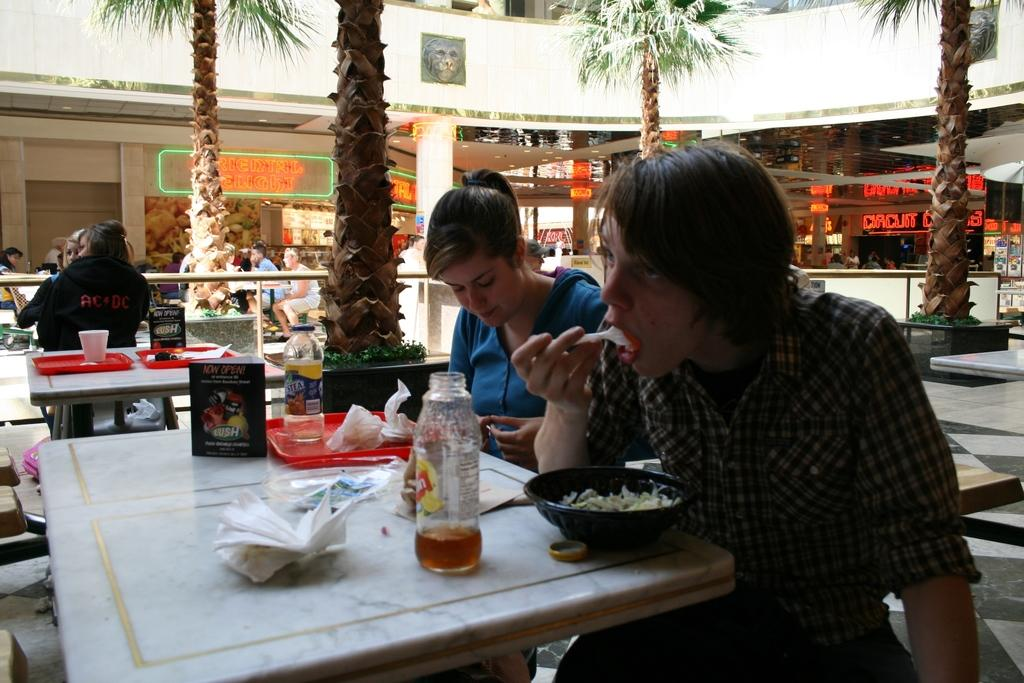What are the people in the image doing? The people in the image are sitting on chairs. What is on the table in the image? There is a table in the image with a bowl, a juice bottle, and napkins on it. What is in the bowl on the table? The bowl contains food. What can be seen in the background of the image? There are trees visible in the background of the image. Is there a veil covering the table in the image? No, there is no veil present in the image. What type of rod can be seen holding up the food in the bowl? There is no rod present in the image; the food is contained within the bowl. 